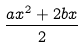Convert formula to latex. <formula><loc_0><loc_0><loc_500><loc_500>\frac { a x ^ { 2 } + 2 b x } { 2 }</formula> 